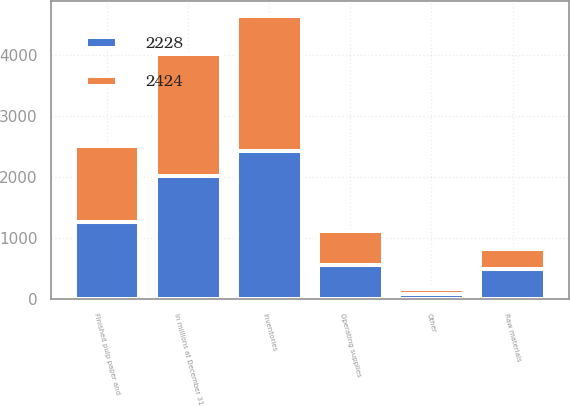<chart> <loc_0><loc_0><loc_500><loc_500><stacked_bar_chart><ecel><fcel>In millions at December 31<fcel>Raw materials<fcel>Finished pulp paper and<fcel>Operating supplies<fcel>Other<fcel>Inventories<nl><fcel>2424<fcel>2015<fcel>339<fcel>1248<fcel>563<fcel>78<fcel>2228<nl><fcel>2228<fcel>2014<fcel>494<fcel>1273<fcel>562<fcel>95<fcel>2424<nl></chart> 